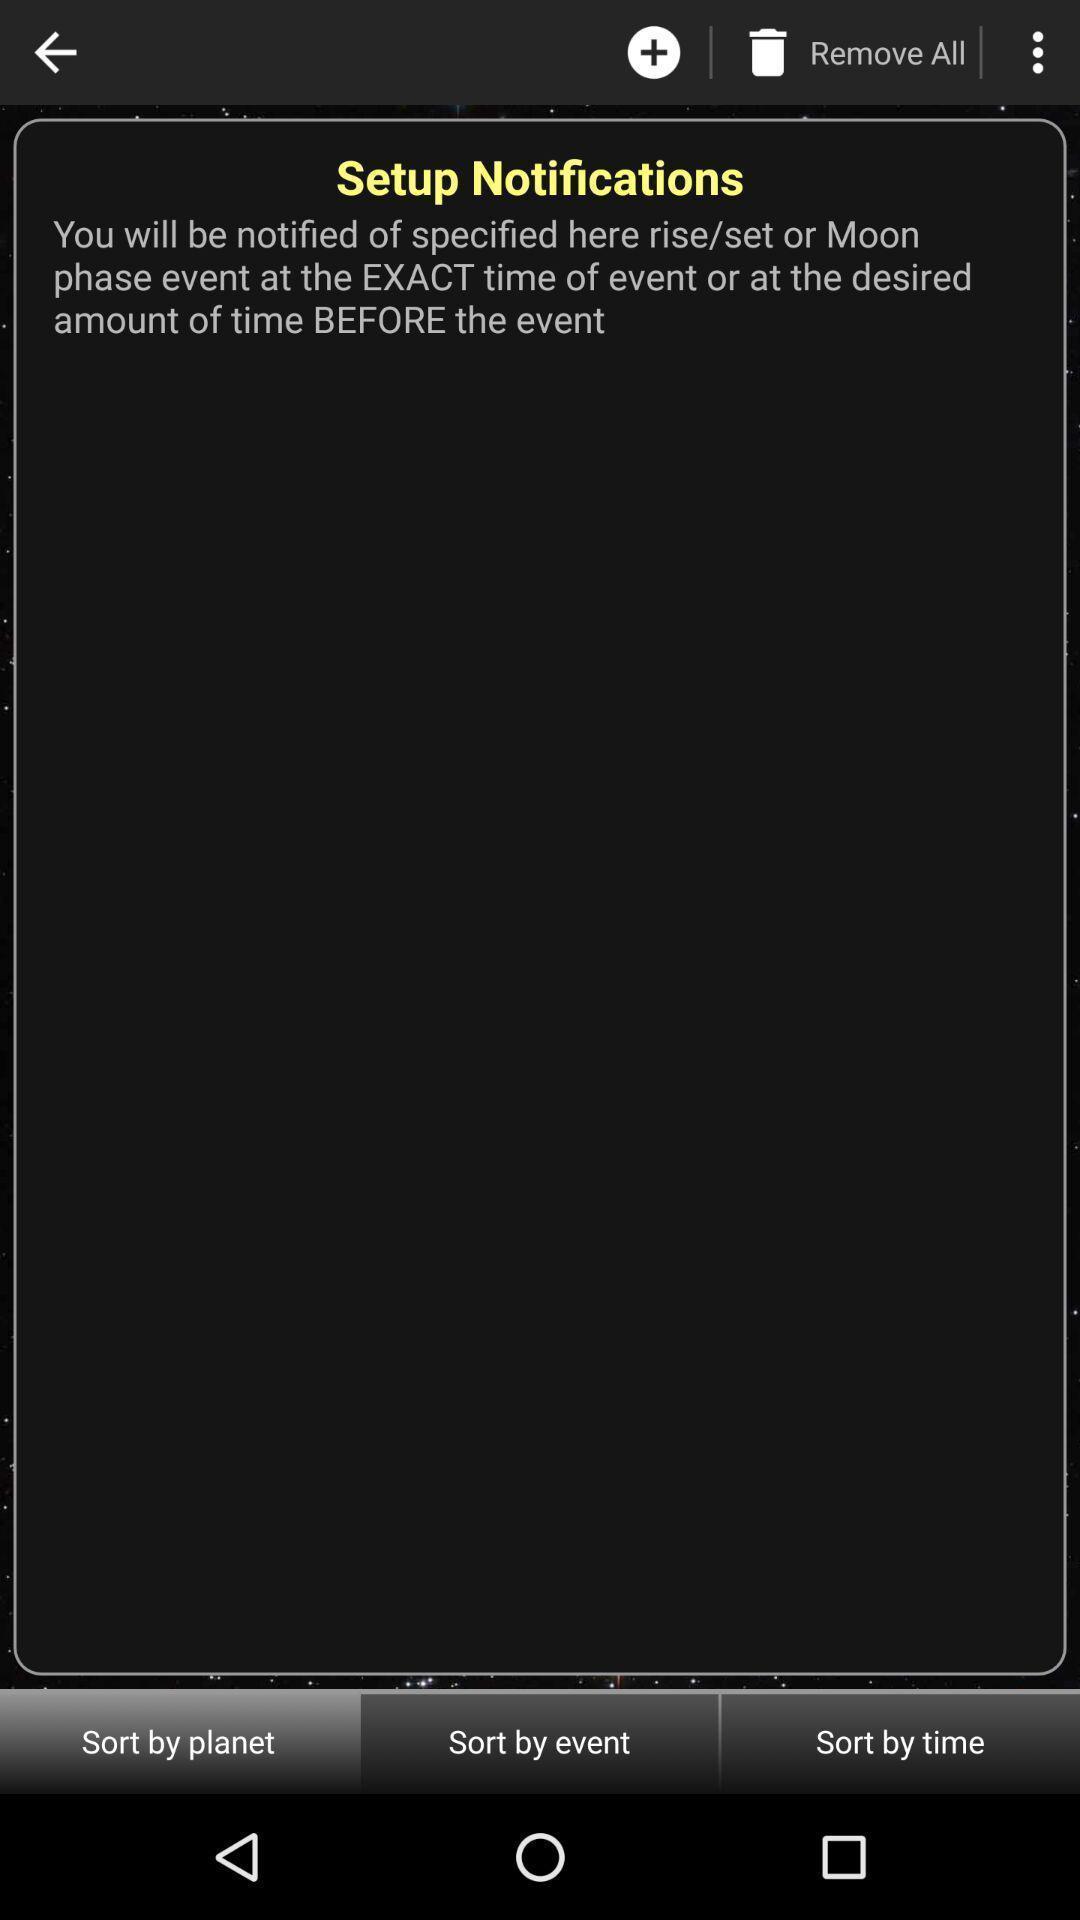Provide a description of this screenshot. Screen displaying multiple sorting options. 